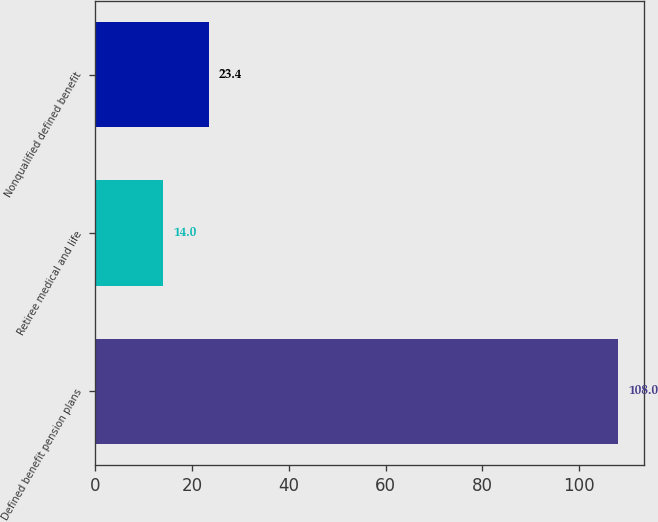<chart> <loc_0><loc_0><loc_500><loc_500><bar_chart><fcel>Defined benefit pension plans<fcel>Retiree medical and life<fcel>Nonqualified defined benefit<nl><fcel>108<fcel>14<fcel>23.4<nl></chart> 